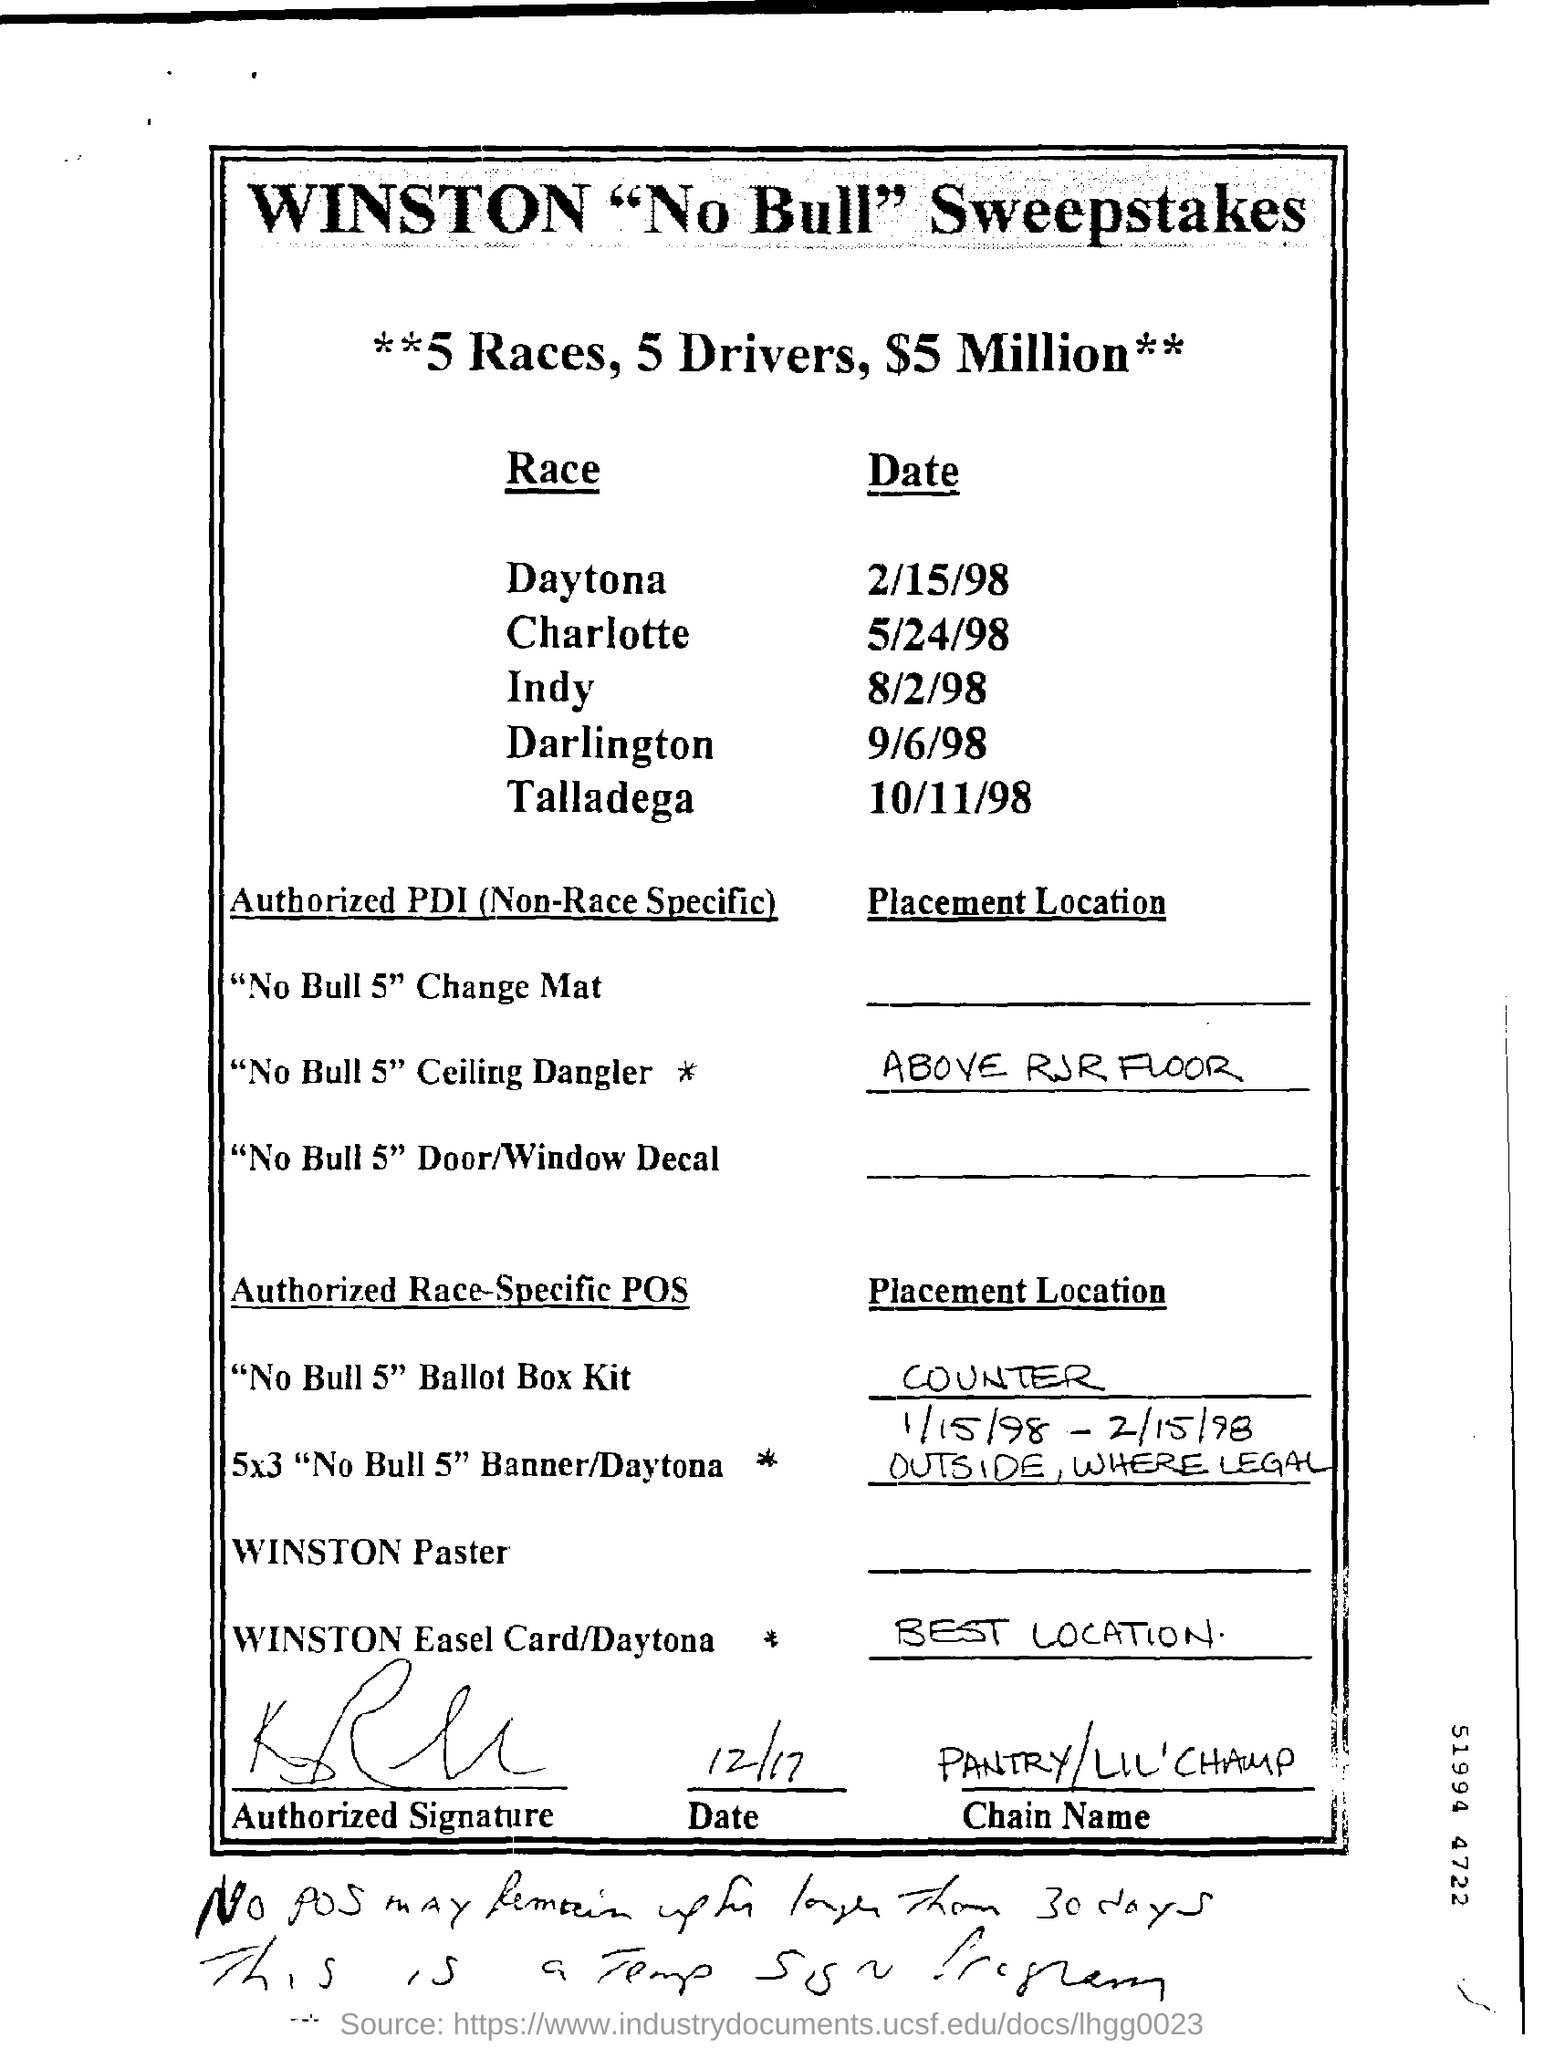Give some essential details in this illustration. The date of the Charlotte race is May 24, 1998. The race that took place on September 6, 1998, at Darlington Raceway was the "Which race? The Daytona race, which was held on 2/15/98, is a well-known event in the world of motorsports. The Indy race will be held on August 2, 1998. On October 11th, 1998, the Talladega race was held. 